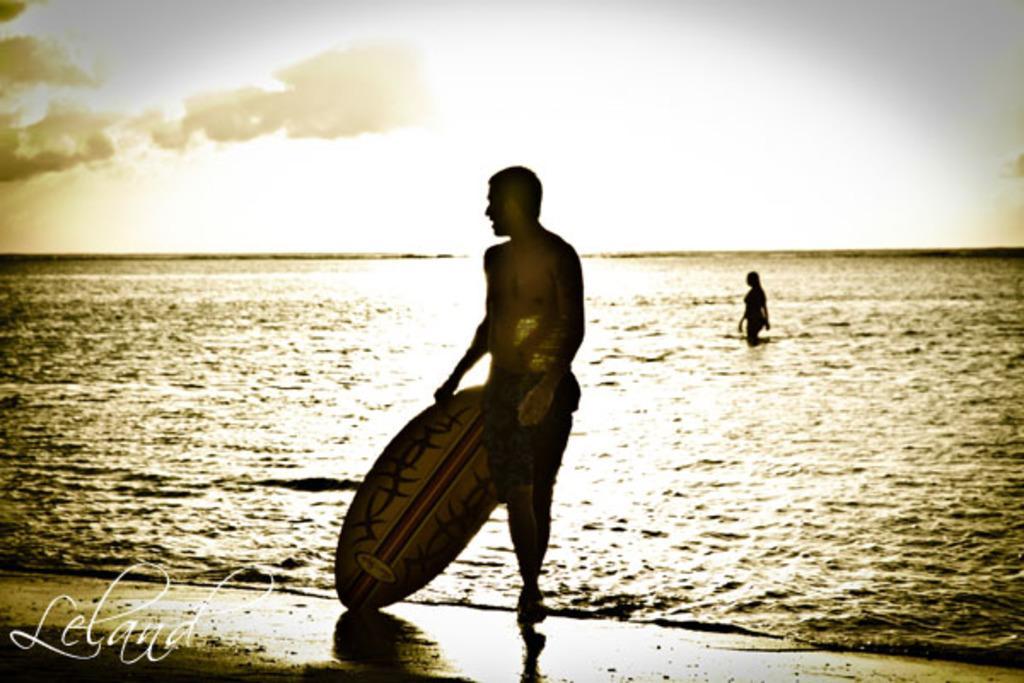Describe this image in one or two sentences. On the background we can see sky with clouds. This is a sea and we can see a woman here. In Front of the sea there is a man , standing and holding a surfboard in his hand. 